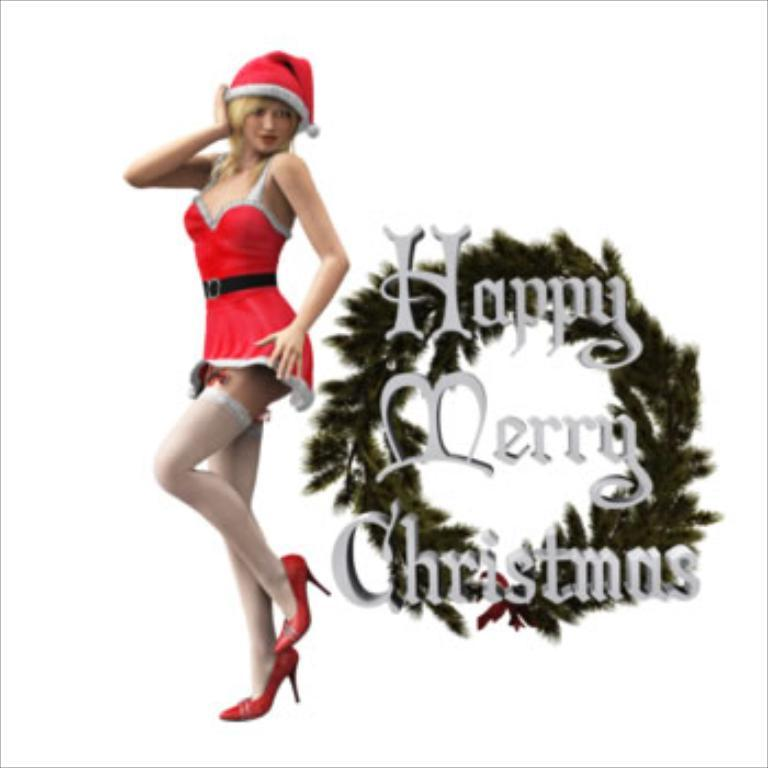Who is present in the image? There is a woman in the image. What is the woman wearing? The woman is wearing a red dress. Can you tell if the image has been altered in any way? Yes, the image has been edited. What is the theme or message of the image? There are Christmas wishes in the image. What type of tin can be seen in the woman's hand in the image? There is no tin present in the woman's hand or in the image. What kind of silk fabric is used to make the woman's dress? The provided facts do not mention the material of the dress, so it cannot be determined from the image. 